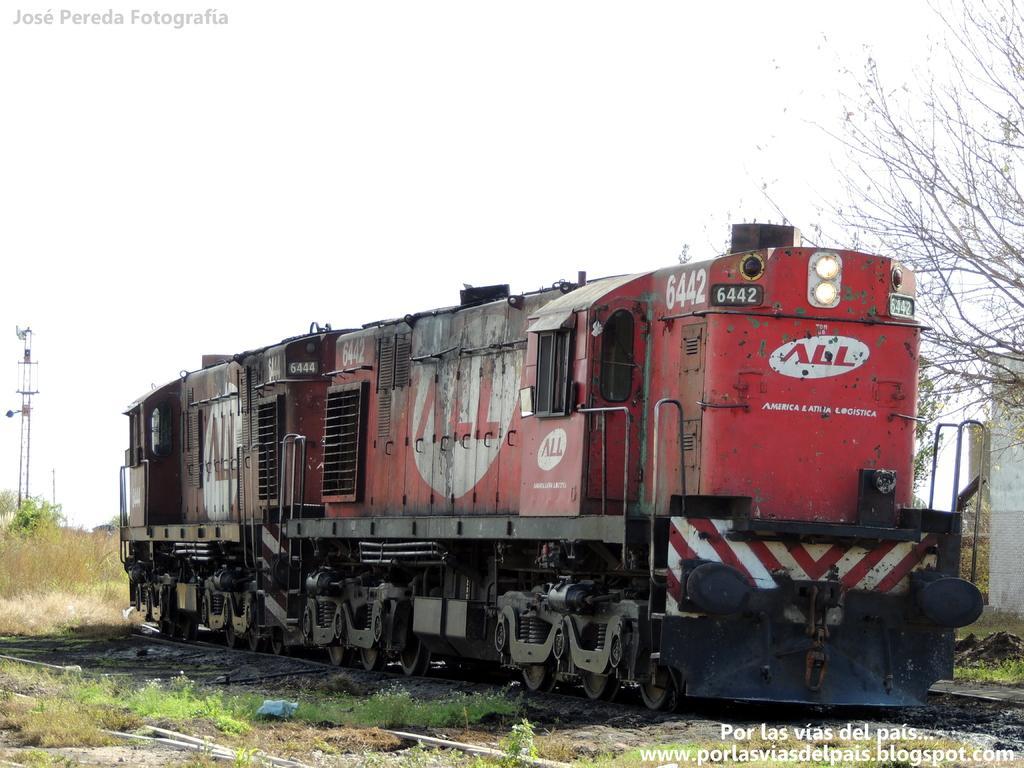Can you describe this image briefly? In this picture we can see train on the track, beside we can see trees, grass and towers. 